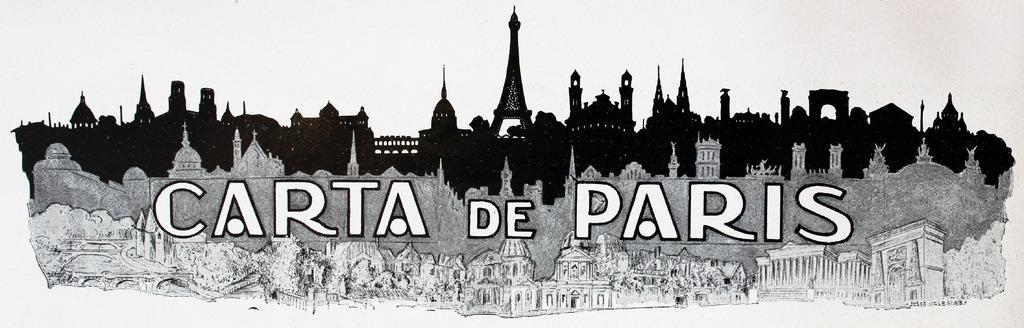What type of image is being described? The image is a black and white animated picture. What is the main subject of the picture? The picture depicts buildings. Are there any words or letters on the picture? Yes, there is text written on the picture. What color is the background behind the buildings? The background behind the buildings is white. Can you tell me how many deer are visible in the image? There are no deer present in the image; it features buildings and text in a black and white animated picture with a white background. What invention is being showcased in the image? There is no invention being showcased in the image; it depicts buildings and text in a black and white animated picture with a white background. 